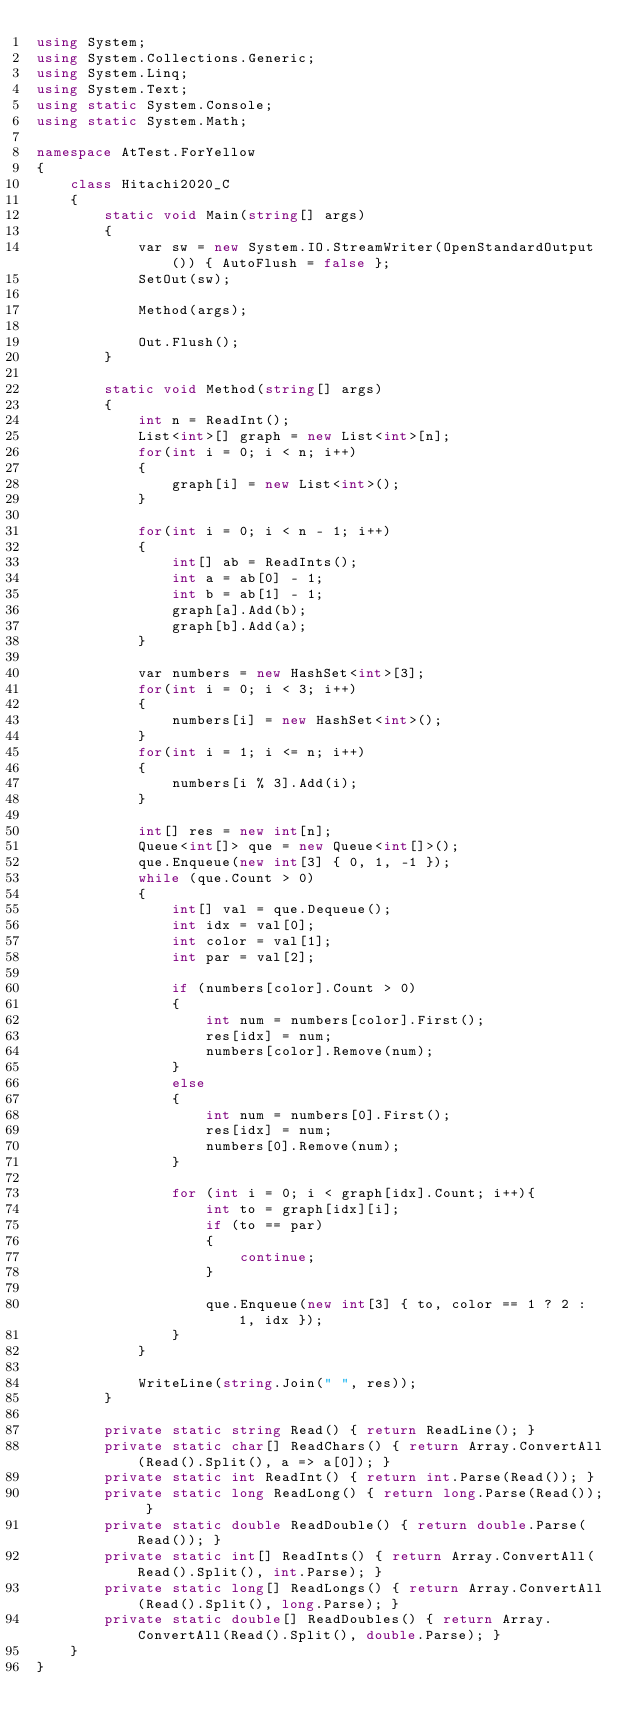<code> <loc_0><loc_0><loc_500><loc_500><_C#_>using System;
using System.Collections.Generic;
using System.Linq;
using System.Text;
using static System.Console;
using static System.Math;

namespace AtTest.ForYellow
{
    class Hitachi2020_C
    {
        static void Main(string[] args)
        {
            var sw = new System.IO.StreamWriter(OpenStandardOutput()) { AutoFlush = false };
            SetOut(sw);

            Method(args);

            Out.Flush();
        }

        static void Method(string[] args)
        {
            int n = ReadInt();
            List<int>[] graph = new List<int>[n];
            for(int i = 0; i < n; i++)
            {
                graph[i] = new List<int>();
            }

            for(int i = 0; i < n - 1; i++)
            {
                int[] ab = ReadInts();
                int a = ab[0] - 1;
                int b = ab[1] - 1;
                graph[a].Add(b);
                graph[b].Add(a);
            }

            var numbers = new HashSet<int>[3];
            for(int i = 0; i < 3; i++)
            {
                numbers[i] = new HashSet<int>();
            }
            for(int i = 1; i <= n; i++)
            {
                numbers[i % 3].Add(i);
            }

            int[] res = new int[n];
            Queue<int[]> que = new Queue<int[]>();
            que.Enqueue(new int[3] { 0, 1, -1 });
            while (que.Count > 0)
            {
                int[] val = que.Dequeue();
                int idx = val[0];
                int color = val[1];
                int par = val[2];

                if (numbers[color].Count > 0)
                {
                    int num = numbers[color].First();
                    res[idx] = num;
                    numbers[color].Remove(num);
                }
                else
                {
                    int num = numbers[0].First();
                    res[idx] = num;
                    numbers[0].Remove(num);
                }

                for (int i = 0; i < graph[idx].Count; i++){
                    int to = graph[idx][i];
                    if (to == par)
                    {
                        continue;
                    }

                    que.Enqueue(new int[3] { to, color == 1 ? 2 : 1, idx });
                }
            }

            WriteLine(string.Join(" ", res));
        }

        private static string Read() { return ReadLine(); }
        private static char[] ReadChars() { return Array.ConvertAll(Read().Split(), a => a[0]); }
        private static int ReadInt() { return int.Parse(Read()); }
        private static long ReadLong() { return long.Parse(Read()); }
        private static double ReadDouble() { return double.Parse(Read()); }
        private static int[] ReadInts() { return Array.ConvertAll(Read().Split(), int.Parse); }
        private static long[] ReadLongs() { return Array.ConvertAll(Read().Split(), long.Parse); }
        private static double[] ReadDoubles() { return Array.ConvertAll(Read().Split(), double.Parse); }
    }
}
</code> 